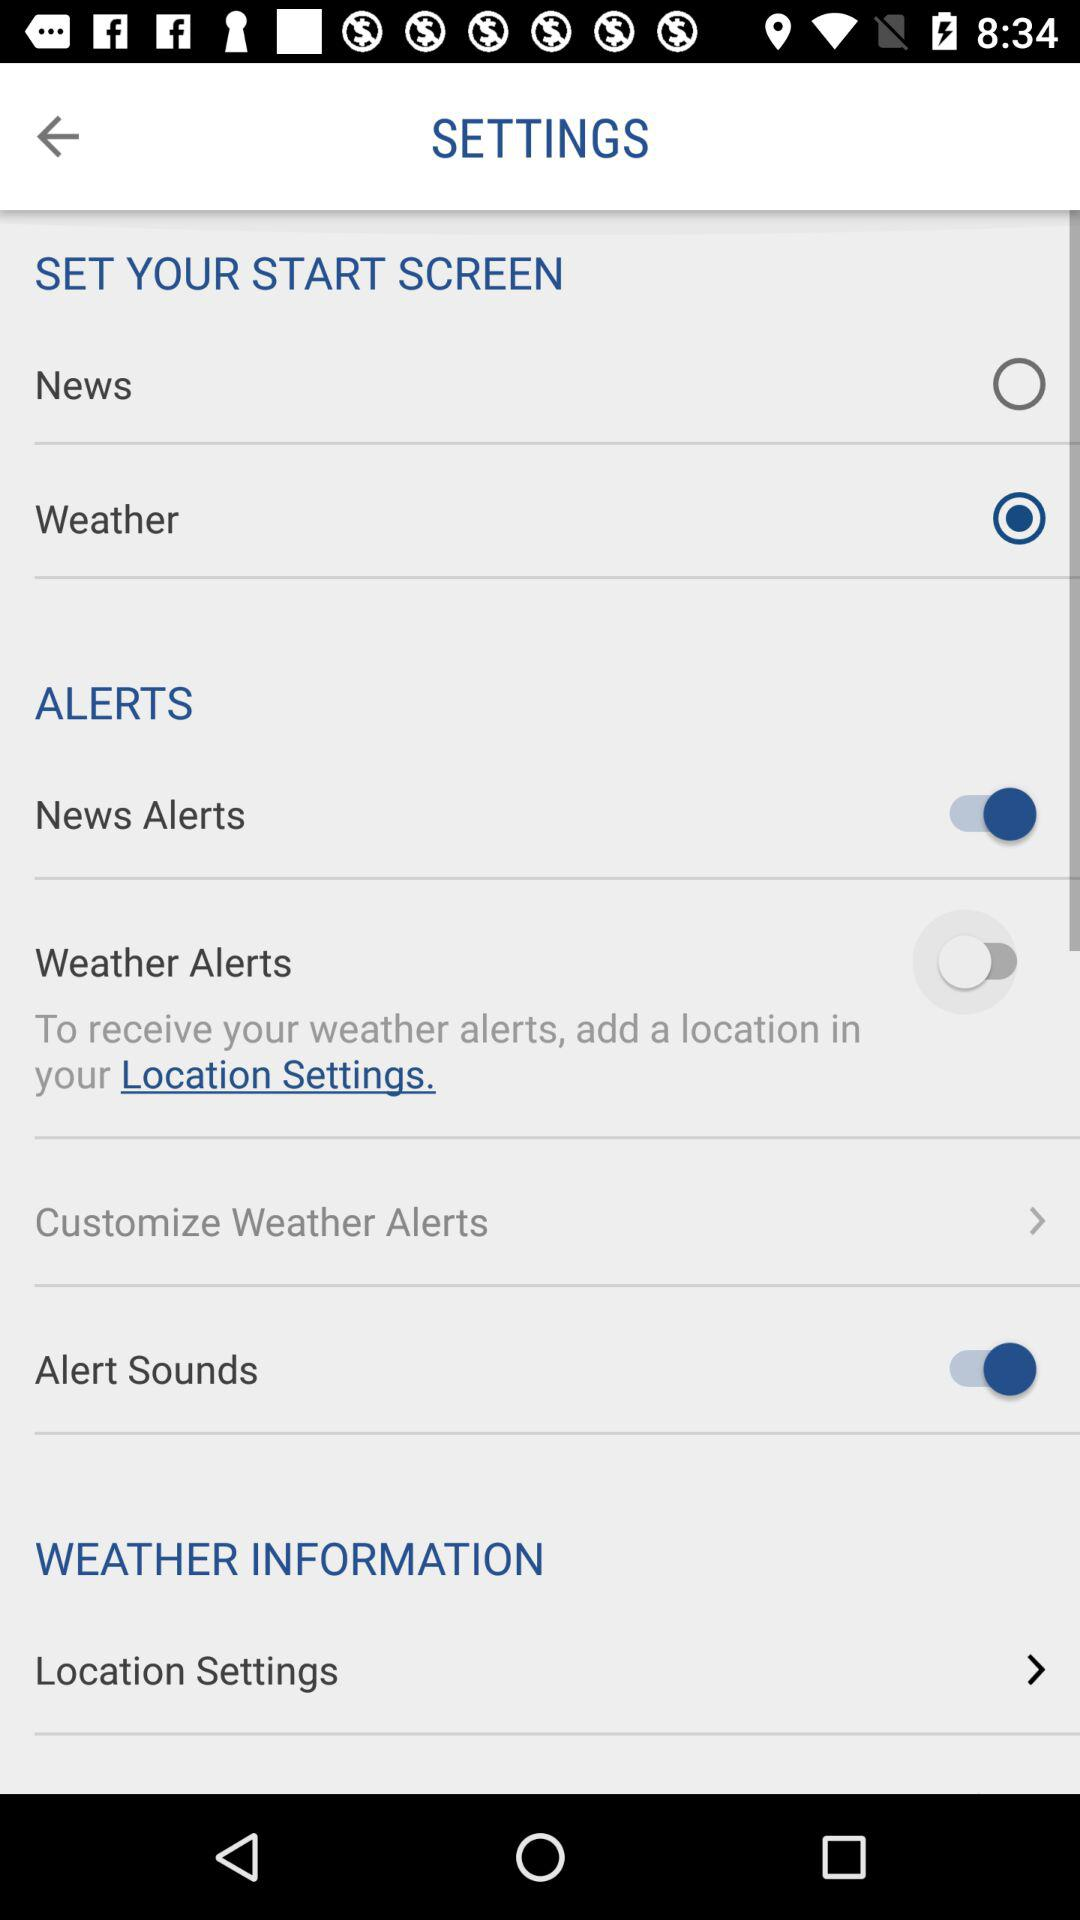What is the status of the "News Alerts"? The status is "on". 